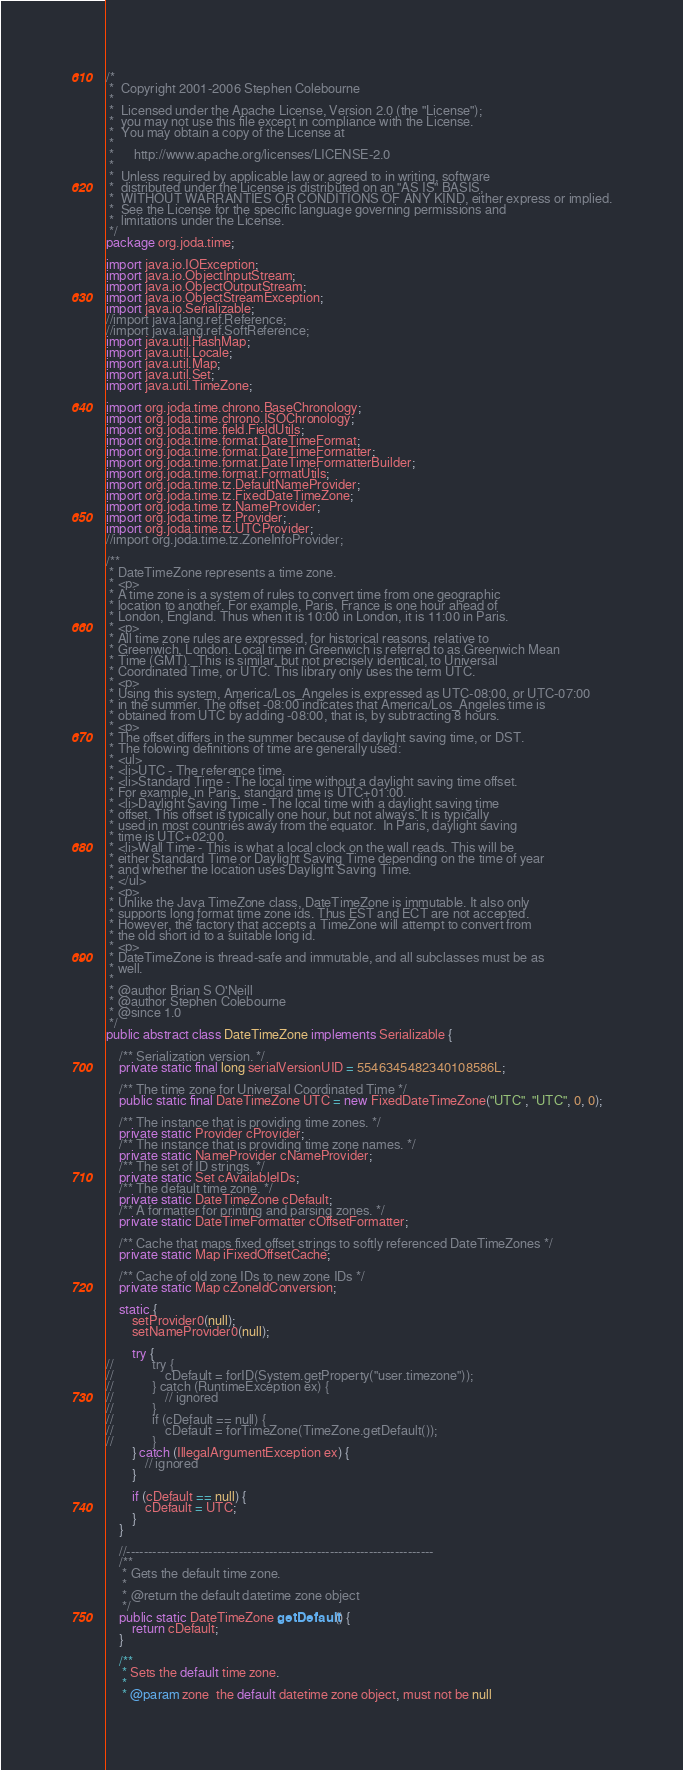Convert code to text. <code><loc_0><loc_0><loc_500><loc_500><_Java_>/*
 *  Copyright 2001-2006 Stephen Colebourne
 *
 *  Licensed under the Apache License, Version 2.0 (the "License");
 *  you may not use this file except in compliance with the License.
 *  You may obtain a copy of the License at
 *
 *      http://www.apache.org/licenses/LICENSE-2.0
 *
 *  Unless required by applicable law or agreed to in writing, software
 *  distributed under the License is distributed on an "AS IS" BASIS,
 *  WITHOUT WARRANTIES OR CONDITIONS OF ANY KIND, either express or implied.
 *  See the License for the specific language governing permissions and
 *  limitations under the License.
 */
package org.joda.time;

import java.io.IOException;
import java.io.ObjectInputStream;
import java.io.ObjectOutputStream;
import java.io.ObjectStreamException;
import java.io.Serializable;
//import java.lang.ref.Reference;
//import java.lang.ref.SoftReference;
import java.util.HashMap;
import java.util.Locale;
import java.util.Map;
import java.util.Set;
import java.util.TimeZone;

import org.joda.time.chrono.BaseChronology;
import org.joda.time.chrono.ISOChronology;
import org.joda.time.field.FieldUtils;
import org.joda.time.format.DateTimeFormat;
import org.joda.time.format.DateTimeFormatter;
import org.joda.time.format.DateTimeFormatterBuilder;
import org.joda.time.format.FormatUtils;
import org.joda.time.tz.DefaultNameProvider;
import org.joda.time.tz.FixedDateTimeZone;
import org.joda.time.tz.NameProvider;
import org.joda.time.tz.Provider;
import org.joda.time.tz.UTCProvider;
//import org.joda.time.tz.ZoneInfoProvider;

/**
 * DateTimeZone represents a time zone.
 * <p>
 * A time zone is a system of rules to convert time from one geographic 
 * location to another. For example, Paris, France is one hour ahead of
 * London, England. Thus when it is 10:00 in London, it is 11:00 in Paris.
 * <p>
 * All time zone rules are expressed, for historical reasons, relative to
 * Greenwich, London. Local time in Greenwich is referred to as Greenwich Mean
 * Time (GMT).  This is similar, but not precisely identical, to Universal 
 * Coordinated Time, or UTC. This library only uses the term UTC.
 * <p>
 * Using this system, America/Los_Angeles is expressed as UTC-08:00, or UTC-07:00
 * in the summer. The offset -08:00 indicates that America/Los_Angeles time is
 * obtained from UTC by adding -08:00, that is, by subtracting 8 hours.
 * <p>
 * The offset differs in the summer because of daylight saving time, or DST.
 * The folowing definitions of time are generally used:
 * <ul>
 * <li>UTC - The reference time.
 * <li>Standard Time - The local time without a daylight saving time offset.
 * For example, in Paris, standard time is UTC+01:00.
 * <li>Daylight Saving Time - The local time with a daylight saving time 
 * offset. This offset is typically one hour, but not always. It is typically
 * used in most countries away from the equator.  In Paris, daylight saving 
 * time is UTC+02:00.
 * <li>Wall Time - This is what a local clock on the wall reads. This will be
 * either Standard Time or Daylight Saving Time depending on the time of year
 * and whether the location uses Daylight Saving Time.
 * </ul>
 * <p>
 * Unlike the Java TimeZone class, DateTimeZone is immutable. It also only
 * supports long format time zone ids. Thus EST and ECT are not accepted.
 * However, the factory that accepts a TimeZone will attempt to convert from
 * the old short id to a suitable long id.
 * <p>
 * DateTimeZone is thread-safe and immutable, and all subclasses must be as
 * well.
 * 
 * @author Brian S O'Neill
 * @author Stephen Colebourne
 * @since 1.0
 */
public abstract class DateTimeZone implements Serializable {
    
    /** Serialization version. */
    private static final long serialVersionUID = 5546345482340108586L;

    /** The time zone for Universal Coordinated Time */
    public static final DateTimeZone UTC = new FixedDateTimeZone("UTC", "UTC", 0, 0);

    /** The instance that is providing time zones. */
    private static Provider cProvider;
    /** The instance that is providing time zone names. */
    private static NameProvider cNameProvider;
    /** The set of ID strings. */
    private static Set cAvailableIDs;
    /** The default time zone. */
    private static DateTimeZone cDefault;
    /** A formatter for printing and parsing zones. */
    private static DateTimeFormatter cOffsetFormatter;

    /** Cache that maps fixed offset strings to softly referenced DateTimeZones */
    private static Map iFixedOffsetCache;

    /** Cache of old zone IDs to new zone IDs */
    private static Map cZoneIdConversion;

    static {
        setProvider0(null);
        setNameProvider0(null);

        try {
//            try {
//                cDefault = forID(System.getProperty("user.timezone"));
//            } catch (RuntimeException ex) {
//                // ignored
//            }
//            if (cDefault == null) {
//                cDefault = forTimeZone(TimeZone.getDefault());
//            }
        } catch (IllegalArgumentException ex) {
            // ignored
        }

        if (cDefault == null) {
            cDefault = UTC;
        }
    }

    //-----------------------------------------------------------------------
    /**
     * Gets the default time zone.
     * 
     * @return the default datetime zone object
     */
    public static DateTimeZone getDefault() {
        return cDefault;
    }

    /**
     * Sets the default time zone.
     * 
     * @param zone  the default datetime zone object, must not be null</code> 